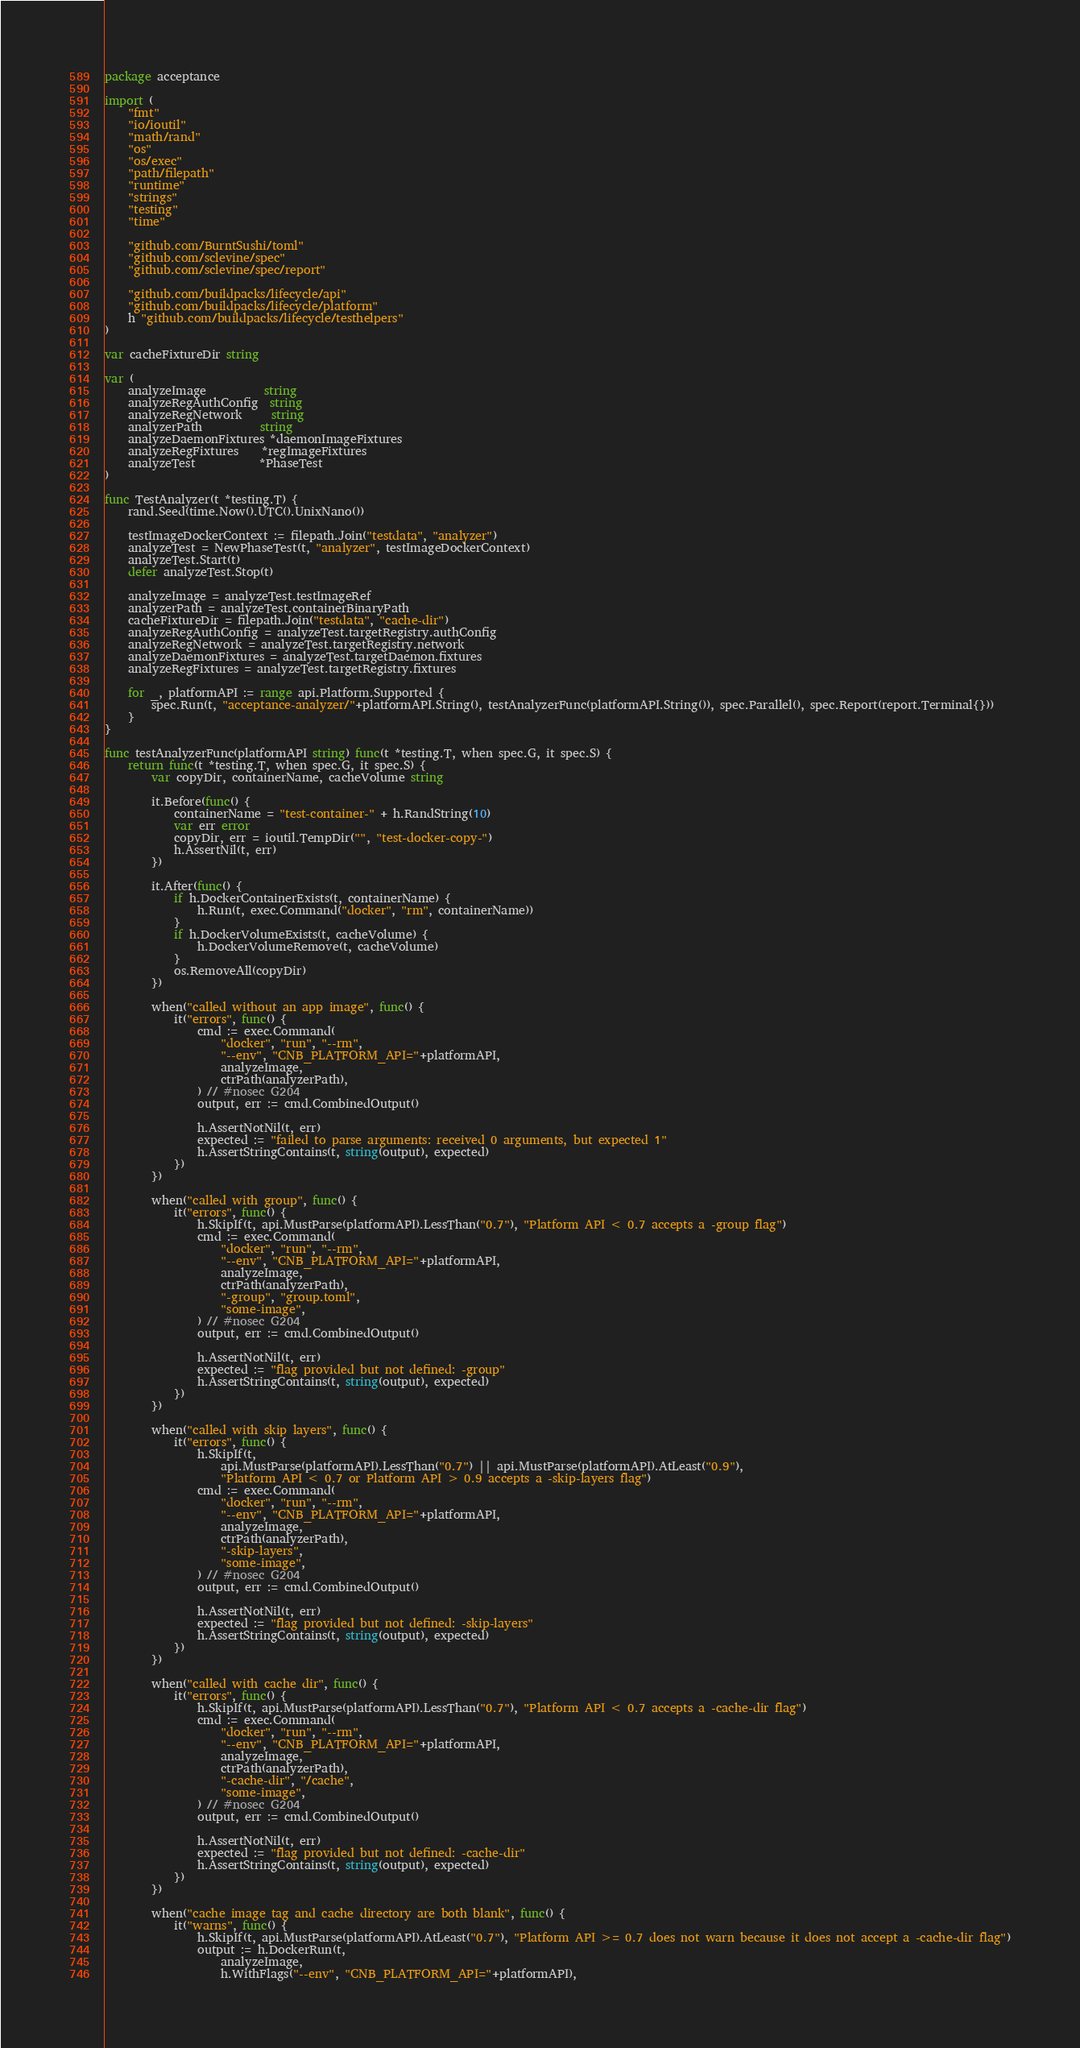<code> <loc_0><loc_0><loc_500><loc_500><_Go_>package acceptance

import (
	"fmt"
	"io/ioutil"
	"math/rand"
	"os"
	"os/exec"
	"path/filepath"
	"runtime"
	"strings"
	"testing"
	"time"

	"github.com/BurntSushi/toml"
	"github.com/sclevine/spec"
	"github.com/sclevine/spec/report"

	"github.com/buildpacks/lifecycle/api"
	"github.com/buildpacks/lifecycle/platform"
	h "github.com/buildpacks/lifecycle/testhelpers"
)

var cacheFixtureDir string

var (
	analyzeImage          string
	analyzeRegAuthConfig  string
	analyzeRegNetwork     string
	analyzerPath          string
	analyzeDaemonFixtures *daemonImageFixtures
	analyzeRegFixtures    *regImageFixtures
	analyzeTest           *PhaseTest
)

func TestAnalyzer(t *testing.T) {
	rand.Seed(time.Now().UTC().UnixNano())

	testImageDockerContext := filepath.Join("testdata", "analyzer")
	analyzeTest = NewPhaseTest(t, "analyzer", testImageDockerContext)
	analyzeTest.Start(t)
	defer analyzeTest.Stop(t)

	analyzeImage = analyzeTest.testImageRef
	analyzerPath = analyzeTest.containerBinaryPath
	cacheFixtureDir = filepath.Join("testdata", "cache-dir")
	analyzeRegAuthConfig = analyzeTest.targetRegistry.authConfig
	analyzeRegNetwork = analyzeTest.targetRegistry.network
	analyzeDaemonFixtures = analyzeTest.targetDaemon.fixtures
	analyzeRegFixtures = analyzeTest.targetRegistry.fixtures

	for _, platformAPI := range api.Platform.Supported {
		spec.Run(t, "acceptance-analyzer/"+platformAPI.String(), testAnalyzerFunc(platformAPI.String()), spec.Parallel(), spec.Report(report.Terminal{}))
	}
}

func testAnalyzerFunc(platformAPI string) func(t *testing.T, when spec.G, it spec.S) {
	return func(t *testing.T, when spec.G, it spec.S) {
		var copyDir, containerName, cacheVolume string

		it.Before(func() {
			containerName = "test-container-" + h.RandString(10)
			var err error
			copyDir, err = ioutil.TempDir("", "test-docker-copy-")
			h.AssertNil(t, err)
		})

		it.After(func() {
			if h.DockerContainerExists(t, containerName) {
				h.Run(t, exec.Command("docker", "rm", containerName))
			}
			if h.DockerVolumeExists(t, cacheVolume) {
				h.DockerVolumeRemove(t, cacheVolume)
			}
			os.RemoveAll(copyDir)
		})

		when("called without an app image", func() {
			it("errors", func() {
				cmd := exec.Command(
					"docker", "run", "--rm",
					"--env", "CNB_PLATFORM_API="+platformAPI,
					analyzeImage,
					ctrPath(analyzerPath),
				) // #nosec G204
				output, err := cmd.CombinedOutput()

				h.AssertNotNil(t, err)
				expected := "failed to parse arguments: received 0 arguments, but expected 1"
				h.AssertStringContains(t, string(output), expected)
			})
		})

		when("called with group", func() {
			it("errors", func() {
				h.SkipIf(t, api.MustParse(platformAPI).LessThan("0.7"), "Platform API < 0.7 accepts a -group flag")
				cmd := exec.Command(
					"docker", "run", "--rm",
					"--env", "CNB_PLATFORM_API="+platformAPI,
					analyzeImage,
					ctrPath(analyzerPath),
					"-group", "group.toml",
					"some-image",
				) // #nosec G204
				output, err := cmd.CombinedOutput()

				h.AssertNotNil(t, err)
				expected := "flag provided but not defined: -group"
				h.AssertStringContains(t, string(output), expected)
			})
		})

		when("called with skip layers", func() {
			it("errors", func() {
				h.SkipIf(t,
					api.MustParse(platformAPI).LessThan("0.7") || api.MustParse(platformAPI).AtLeast("0.9"),
					"Platform API < 0.7 or Platform API > 0.9 accepts a -skip-layers flag")
				cmd := exec.Command(
					"docker", "run", "--rm",
					"--env", "CNB_PLATFORM_API="+platformAPI,
					analyzeImage,
					ctrPath(analyzerPath),
					"-skip-layers",
					"some-image",
				) // #nosec G204
				output, err := cmd.CombinedOutput()

				h.AssertNotNil(t, err)
				expected := "flag provided but not defined: -skip-layers"
				h.AssertStringContains(t, string(output), expected)
			})
		})

		when("called with cache dir", func() {
			it("errors", func() {
				h.SkipIf(t, api.MustParse(platformAPI).LessThan("0.7"), "Platform API < 0.7 accepts a -cache-dir flag")
				cmd := exec.Command(
					"docker", "run", "--rm",
					"--env", "CNB_PLATFORM_API="+platformAPI,
					analyzeImage,
					ctrPath(analyzerPath),
					"-cache-dir", "/cache",
					"some-image",
				) // #nosec G204
				output, err := cmd.CombinedOutput()

				h.AssertNotNil(t, err)
				expected := "flag provided but not defined: -cache-dir"
				h.AssertStringContains(t, string(output), expected)
			})
		})

		when("cache image tag and cache directory are both blank", func() {
			it("warns", func() {
				h.SkipIf(t, api.MustParse(platformAPI).AtLeast("0.7"), "Platform API >= 0.7 does not warn because it does not accept a -cache-dir flag")
				output := h.DockerRun(t,
					analyzeImage,
					h.WithFlags("--env", "CNB_PLATFORM_API="+platformAPI),</code> 